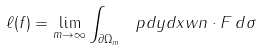<formula> <loc_0><loc_0><loc_500><loc_500>\ell ( f ) = \lim _ { m \to \infty } \int _ { \partial \Omega _ { m } } \ p d y d x { w } { n } \cdot F \, d \sigma</formula> 